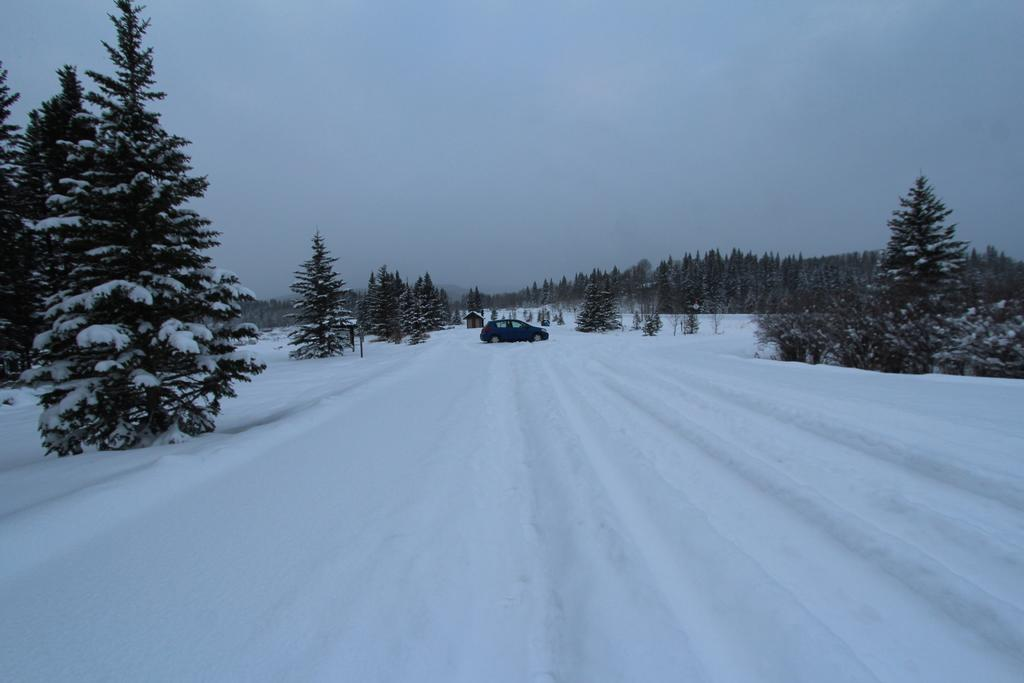What is the main subject of the image? The main subject of the image is a car. How is the car positioned in the image? The car is parked on the ground. What is covering the ground in the image? The ground is covered with snow. What type of natural elements can be seen in the image? There are trees visible in the image. What shape is the unit that the car is driving around in the image? There is no unit present in the image, and the car is parked, not driving. 